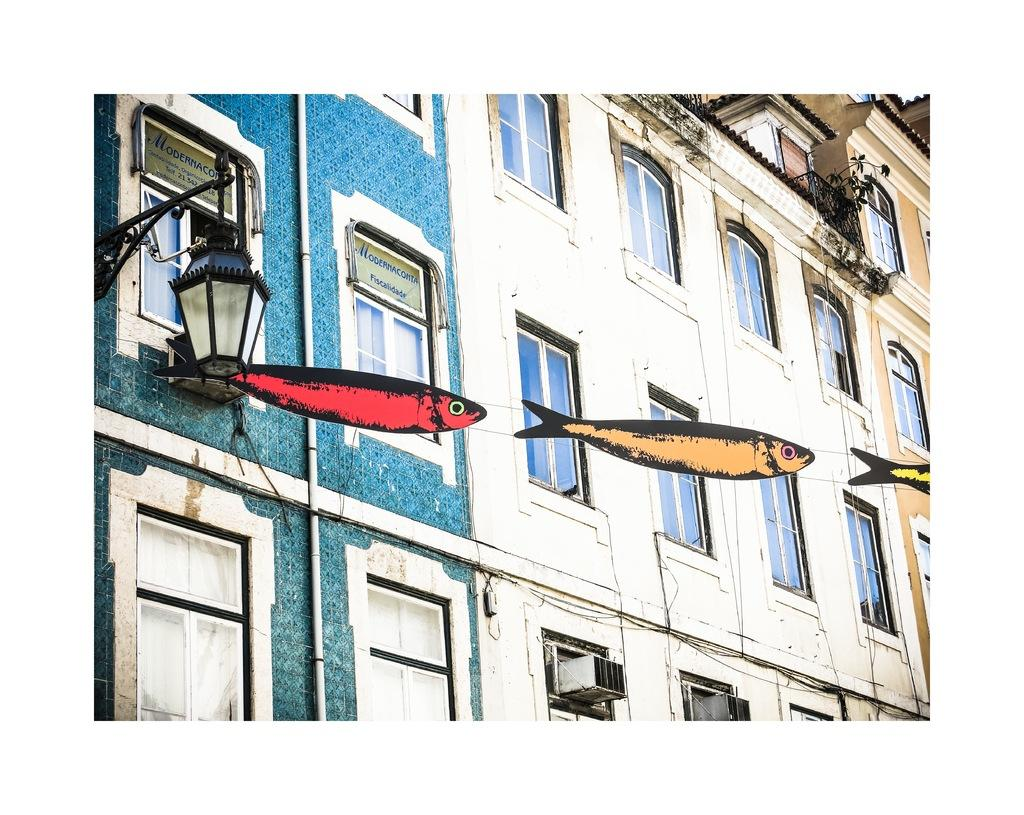What type of structures can be seen in the image? There are buildings in the image. Can you describe any other elements in the image besides the buildings? Yes, there is a light and boards with text visible in the image. What might be used to hang or display the objects in the image? There are objects attached to a rope in the image. What type of floor can be seen in the image? There is no floor visible in the image; it primarily features buildings, a light, boards with text, and objects attached to a rope. 